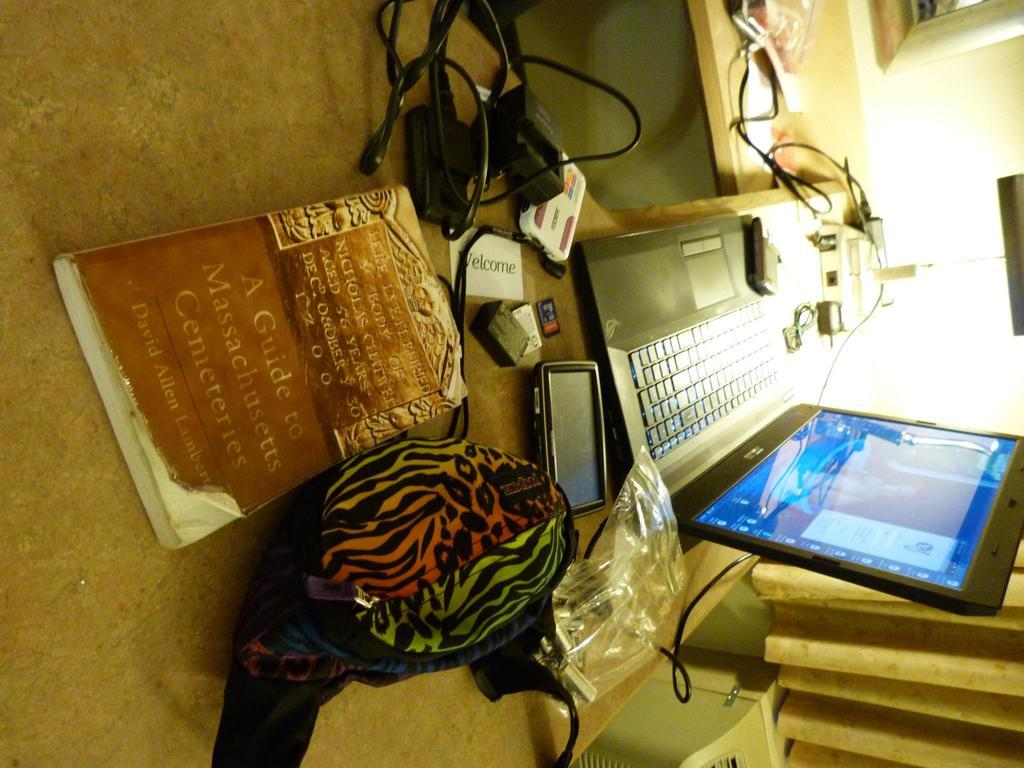What type of table is in the image? There is a wooden table in the image. What electronic device is on the table? A laptop is present on the table. What other items can be seen on the table? A mobile phone, a book, and a bag are on the table. What is the tendency of the minute to take a breath in the image? There is no minute or concept of breath present in the image; it only features a wooden table with various objects on it. 